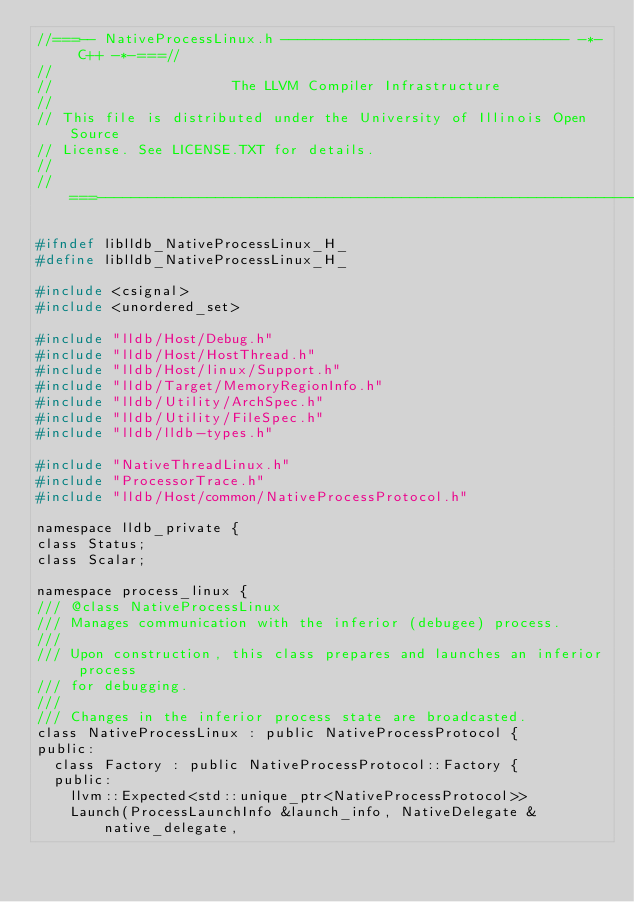Convert code to text. <code><loc_0><loc_0><loc_500><loc_500><_C_>//===-- NativeProcessLinux.h ---------------------------------- -*- C++ -*-===//
//
//                     The LLVM Compiler Infrastructure
//
// This file is distributed under the University of Illinois Open Source
// License. See LICENSE.TXT for details.
//
//===----------------------------------------------------------------------===//

#ifndef liblldb_NativeProcessLinux_H_
#define liblldb_NativeProcessLinux_H_

#include <csignal>
#include <unordered_set>

#include "lldb/Host/Debug.h"
#include "lldb/Host/HostThread.h"
#include "lldb/Host/linux/Support.h"
#include "lldb/Target/MemoryRegionInfo.h"
#include "lldb/Utility/ArchSpec.h"
#include "lldb/Utility/FileSpec.h"
#include "lldb/lldb-types.h"

#include "NativeThreadLinux.h"
#include "ProcessorTrace.h"
#include "lldb/Host/common/NativeProcessProtocol.h"

namespace lldb_private {
class Status;
class Scalar;

namespace process_linux {
/// @class NativeProcessLinux
/// Manages communication with the inferior (debugee) process.
///
/// Upon construction, this class prepares and launches an inferior process
/// for debugging.
///
/// Changes in the inferior process state are broadcasted.
class NativeProcessLinux : public NativeProcessProtocol {
public:
  class Factory : public NativeProcessProtocol::Factory {
  public:
    llvm::Expected<std::unique_ptr<NativeProcessProtocol>>
    Launch(ProcessLaunchInfo &launch_info, NativeDelegate &native_delegate,</code> 